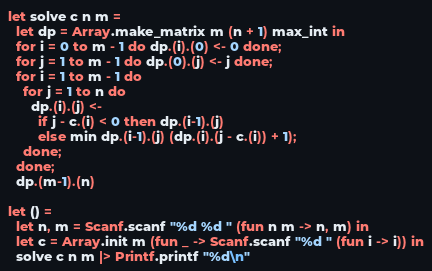Convert code to text. <code><loc_0><loc_0><loc_500><loc_500><_OCaml_>let solve c n m =
  let dp = Array.make_matrix m (n + 1) max_int in
  for i = 0 to m - 1 do dp.(i).(0) <- 0 done;
  for j = 1 to m - 1 do dp.(0).(j) <- j done;
  for i = 1 to m - 1 do
    for j = 1 to n do
      dp.(i).(j) <-
        if j - c.(i) < 0 then dp.(i-1).(j)
        else min dp.(i-1).(j) (dp.(i).(j - c.(i)) + 1);
    done;
  done;
  dp.(m-1).(n)

let () =
  let n, m = Scanf.scanf "%d %d " (fun n m -> n, m) in
  let c = Array.init m (fun _ -> Scanf.scanf "%d " (fun i -> i)) in
  solve c n m |> Printf.printf "%d\n"</code> 